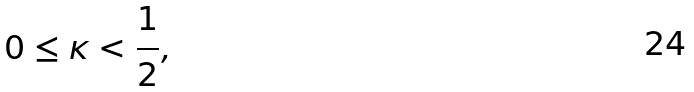Convert formula to latex. <formula><loc_0><loc_0><loc_500><loc_500>0 \leq \kappa < \frac { 1 } { 2 } ,</formula> 